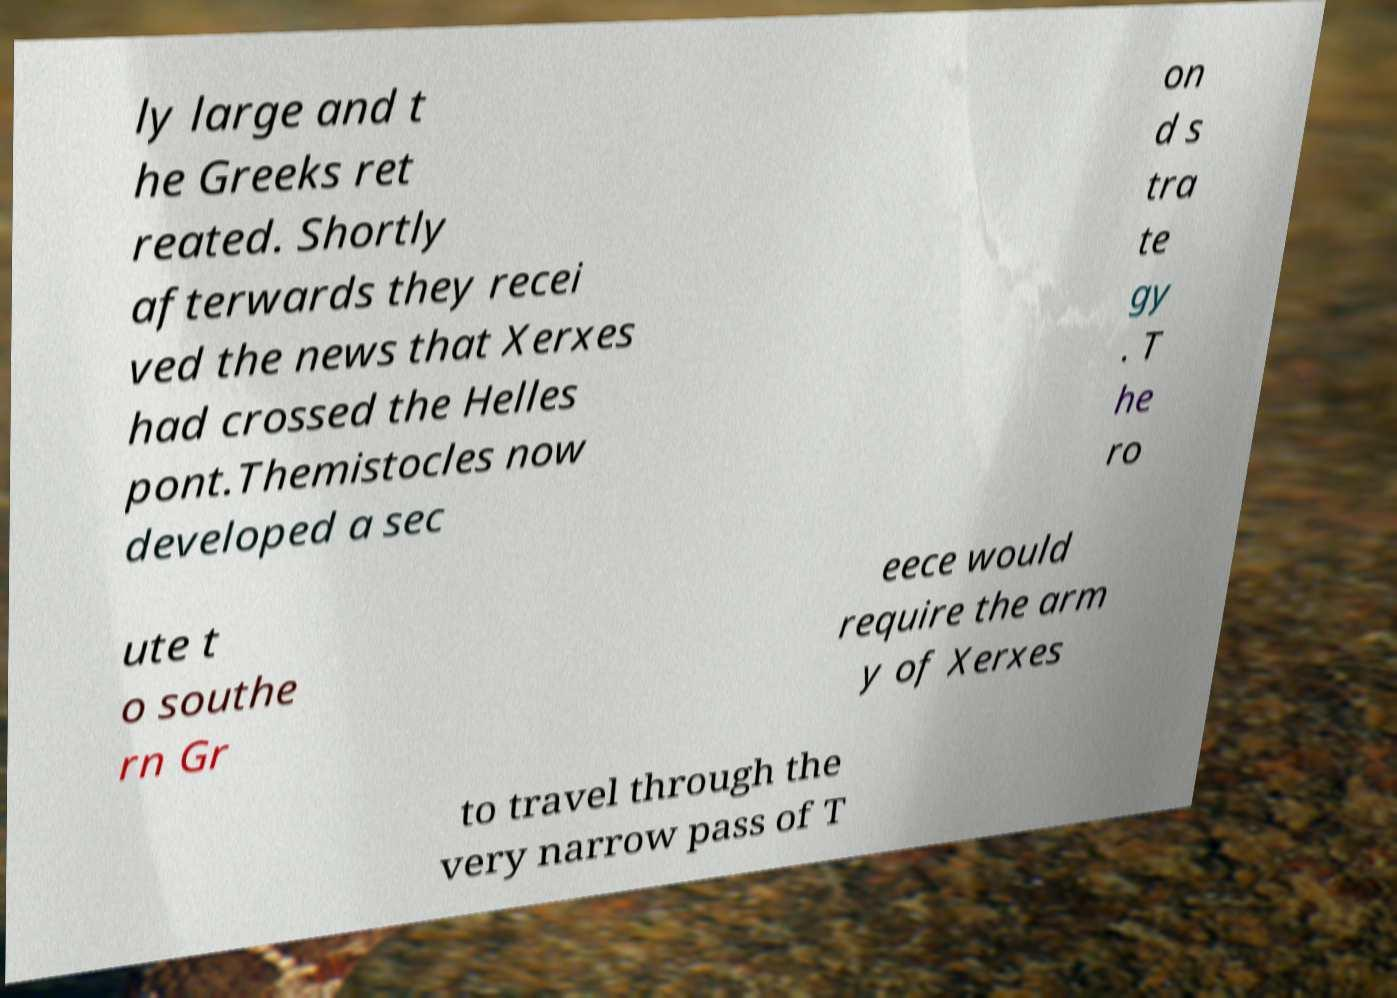Could you extract and type out the text from this image? ly large and t he Greeks ret reated. Shortly afterwards they recei ved the news that Xerxes had crossed the Helles pont.Themistocles now developed a sec on d s tra te gy . T he ro ute t o southe rn Gr eece would require the arm y of Xerxes to travel through the very narrow pass of T 